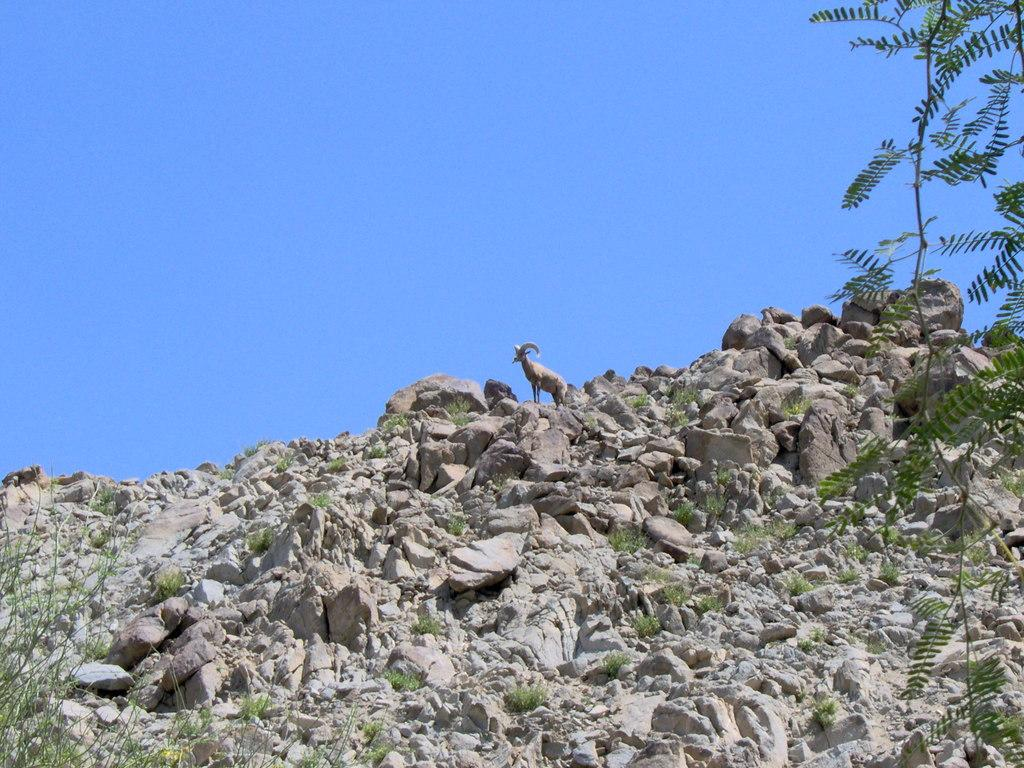What animal can be seen in the image? There is a goat in the image. Where is the goat located? The goat is standing on a rocky hill. What type of vegetation is present in the image? There are plants in the image. What can be seen in the background of the image? The sky is visible in the image. What type of wrench is the goat using to fix the trail in the image? There is no wrench or trail present in the image; it features a goat standing on a rocky hill with plants and a visible sky. 